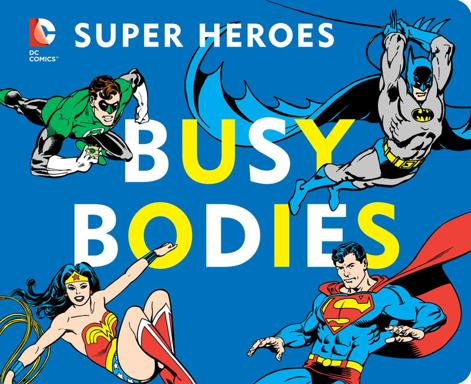Could you explore the artistic style used in this image? The artistic style of the image is reminiscent of vintage comic book art from the mid-20th century, characterized by bold, clear lines and bright, contrasting colors that capture the dynamic and larger-than-life essence of the characters. How does this artistic style contribute to the overall impact of the image? This style enhances the visual impact by making the characters instantly recognizable and engaging. It conveys energy and excitement, which is fundamental in attracting and retaining the viewer's attention, particularly in a nostalgic and iconic context. 